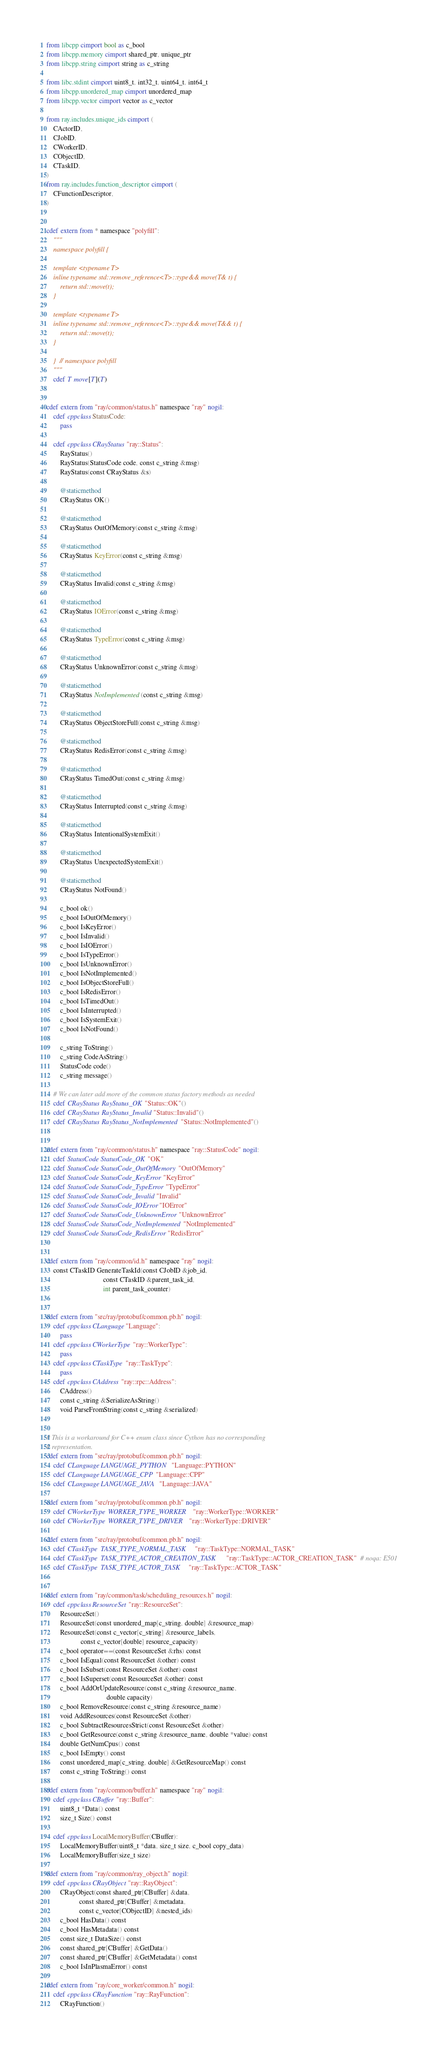<code> <loc_0><loc_0><loc_500><loc_500><_Cython_>from libcpp cimport bool as c_bool
from libcpp.memory cimport shared_ptr, unique_ptr
from libcpp.string cimport string as c_string

from libc.stdint cimport uint8_t, int32_t, uint64_t, int64_t
from libcpp.unordered_map cimport unordered_map
from libcpp.vector cimport vector as c_vector

from ray.includes.unique_ids cimport (
    CActorID,
    CJobID,
    CWorkerID,
    CObjectID,
    CTaskID,
)
from ray.includes.function_descriptor cimport (
    CFunctionDescriptor,
)


cdef extern from * namespace "polyfill":
    """
    namespace polyfill {

    template <typename T>
    inline typename std::remove_reference<T>::type&& move(T& t) {
        return std::move(t);
    }

    template <typename T>
    inline typename std::remove_reference<T>::type&& move(T&& t) {
        return std::move(t);
    }

    }  // namespace polyfill
    """
    cdef T move[T](T)


cdef extern from "ray/common/status.h" namespace "ray" nogil:
    cdef cppclass StatusCode:
        pass

    cdef cppclass CRayStatus "ray::Status":
        RayStatus()
        RayStatus(StatusCode code, const c_string &msg)
        RayStatus(const CRayStatus &s)

        @staticmethod
        CRayStatus OK()

        @staticmethod
        CRayStatus OutOfMemory(const c_string &msg)

        @staticmethod
        CRayStatus KeyError(const c_string &msg)

        @staticmethod
        CRayStatus Invalid(const c_string &msg)

        @staticmethod
        CRayStatus IOError(const c_string &msg)

        @staticmethod
        CRayStatus TypeError(const c_string &msg)

        @staticmethod
        CRayStatus UnknownError(const c_string &msg)

        @staticmethod
        CRayStatus NotImplemented(const c_string &msg)

        @staticmethod
        CRayStatus ObjectStoreFull(const c_string &msg)

        @staticmethod
        CRayStatus RedisError(const c_string &msg)

        @staticmethod
        CRayStatus TimedOut(const c_string &msg)

        @staticmethod
        CRayStatus Interrupted(const c_string &msg)

        @staticmethod
        CRayStatus IntentionalSystemExit()

        @staticmethod
        CRayStatus UnexpectedSystemExit()

        @staticmethod
        CRayStatus NotFound()

        c_bool ok()
        c_bool IsOutOfMemory()
        c_bool IsKeyError()
        c_bool IsInvalid()
        c_bool IsIOError()
        c_bool IsTypeError()
        c_bool IsUnknownError()
        c_bool IsNotImplemented()
        c_bool IsObjectStoreFull()
        c_bool IsRedisError()
        c_bool IsTimedOut()
        c_bool IsInterrupted()
        c_bool IsSystemExit()
        c_bool IsNotFound()

        c_string ToString()
        c_string CodeAsString()
        StatusCode code()
        c_string message()

    # We can later add more of the common status factory methods as needed
    cdef CRayStatus RayStatus_OK "Status::OK"()
    cdef CRayStatus RayStatus_Invalid "Status::Invalid"()
    cdef CRayStatus RayStatus_NotImplemented "Status::NotImplemented"()


cdef extern from "ray/common/status.h" namespace "ray::StatusCode" nogil:
    cdef StatusCode StatusCode_OK "OK"
    cdef StatusCode StatusCode_OutOfMemory "OutOfMemory"
    cdef StatusCode StatusCode_KeyError "KeyError"
    cdef StatusCode StatusCode_TypeError "TypeError"
    cdef StatusCode StatusCode_Invalid "Invalid"
    cdef StatusCode StatusCode_IOError "IOError"
    cdef StatusCode StatusCode_UnknownError "UnknownError"
    cdef StatusCode StatusCode_NotImplemented "NotImplemented"
    cdef StatusCode StatusCode_RedisError "RedisError"


cdef extern from "ray/common/id.h" namespace "ray" nogil:
    const CTaskID GenerateTaskId(const CJobID &job_id,
                                 const CTaskID &parent_task_id,
                                 int parent_task_counter)


cdef extern from "src/ray/protobuf/common.pb.h" nogil:
    cdef cppclass CLanguage "Language":
        pass
    cdef cppclass CWorkerType "ray::WorkerType":
        pass
    cdef cppclass CTaskType "ray::TaskType":
        pass
    cdef cppclass CAddress "ray::rpc::Address":
        CAddress()
        const c_string &SerializeAsString()
        void ParseFromString(const c_string &serialized)


# This is a workaround for C++ enum class since Cython has no corresponding
# representation.
cdef extern from "src/ray/protobuf/common.pb.h" nogil:
    cdef CLanguage LANGUAGE_PYTHON "Language::PYTHON"
    cdef CLanguage LANGUAGE_CPP "Language::CPP"
    cdef CLanguage LANGUAGE_JAVA "Language::JAVA"

cdef extern from "src/ray/protobuf/common.pb.h" nogil:
    cdef CWorkerType WORKER_TYPE_WORKER "ray::WorkerType::WORKER"
    cdef CWorkerType WORKER_TYPE_DRIVER "ray::WorkerType::DRIVER"

cdef extern from "src/ray/protobuf/common.pb.h" nogil:
    cdef CTaskType TASK_TYPE_NORMAL_TASK "ray::TaskType::NORMAL_TASK"
    cdef CTaskType TASK_TYPE_ACTOR_CREATION_TASK "ray::TaskType::ACTOR_CREATION_TASK"  # noqa: E501
    cdef CTaskType TASK_TYPE_ACTOR_TASK "ray::TaskType::ACTOR_TASK"


cdef extern from "ray/common/task/scheduling_resources.h" nogil:
    cdef cppclass ResourceSet "ray::ResourceSet":
        ResourceSet()
        ResourceSet(const unordered_map[c_string, double] &resource_map)
        ResourceSet(const c_vector[c_string] &resource_labels,
                    const c_vector[double] resource_capacity)
        c_bool operator==(const ResourceSet &rhs) const
        c_bool IsEqual(const ResourceSet &other) const
        c_bool IsSubset(const ResourceSet &other) const
        c_bool IsSuperset(const ResourceSet &other) const
        c_bool AddOrUpdateResource(const c_string &resource_name,
                                   double capacity)
        c_bool RemoveResource(const c_string &resource_name)
        void AddResources(const ResourceSet &other)
        c_bool SubtractResourcesStrict(const ResourceSet &other)
        c_bool GetResource(const c_string &resource_name, double *value) const
        double GetNumCpus() const
        c_bool IsEmpty() const
        const unordered_map[c_string, double] &GetResourceMap() const
        const c_string ToString() const

cdef extern from "ray/common/buffer.h" namespace "ray" nogil:
    cdef cppclass CBuffer "ray::Buffer":
        uint8_t *Data() const
        size_t Size() const

    cdef cppclass LocalMemoryBuffer(CBuffer):
        LocalMemoryBuffer(uint8_t *data, size_t size, c_bool copy_data)
        LocalMemoryBuffer(size_t size)

cdef extern from "ray/common/ray_object.h" nogil:
    cdef cppclass CRayObject "ray::RayObject":
        CRayObject(const shared_ptr[CBuffer] &data,
                   const shared_ptr[CBuffer] &metadata,
                   const c_vector[CObjectID] &nested_ids)
        c_bool HasData() const
        c_bool HasMetadata() const
        const size_t DataSize() const
        const shared_ptr[CBuffer] &GetData()
        const shared_ptr[CBuffer] &GetMetadata() const
        c_bool IsInPlasmaError() const

cdef extern from "ray/core_worker/common.h" nogil:
    cdef cppclass CRayFunction "ray::RayFunction":
        CRayFunction()</code> 